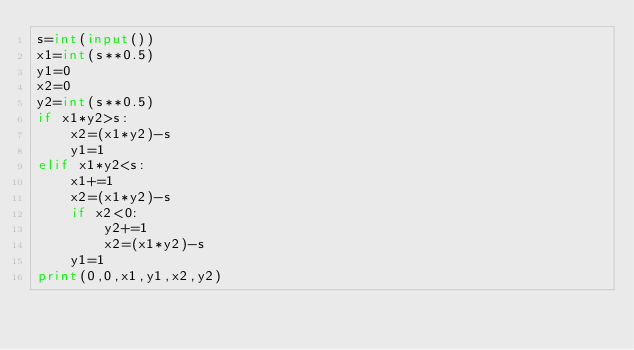Convert code to text. <code><loc_0><loc_0><loc_500><loc_500><_Python_>s=int(input())
x1=int(s**0.5)
y1=0
x2=0
y2=int(s**0.5)
if x1*y2>s:
    x2=(x1*y2)-s
    y1=1
elif x1*y2<s:
    x1+=1
    x2=(x1*y2)-s
    if x2<0:
        y2+=1
        x2=(x1*y2)-s
    y1=1
print(0,0,x1,y1,x2,y2)</code> 